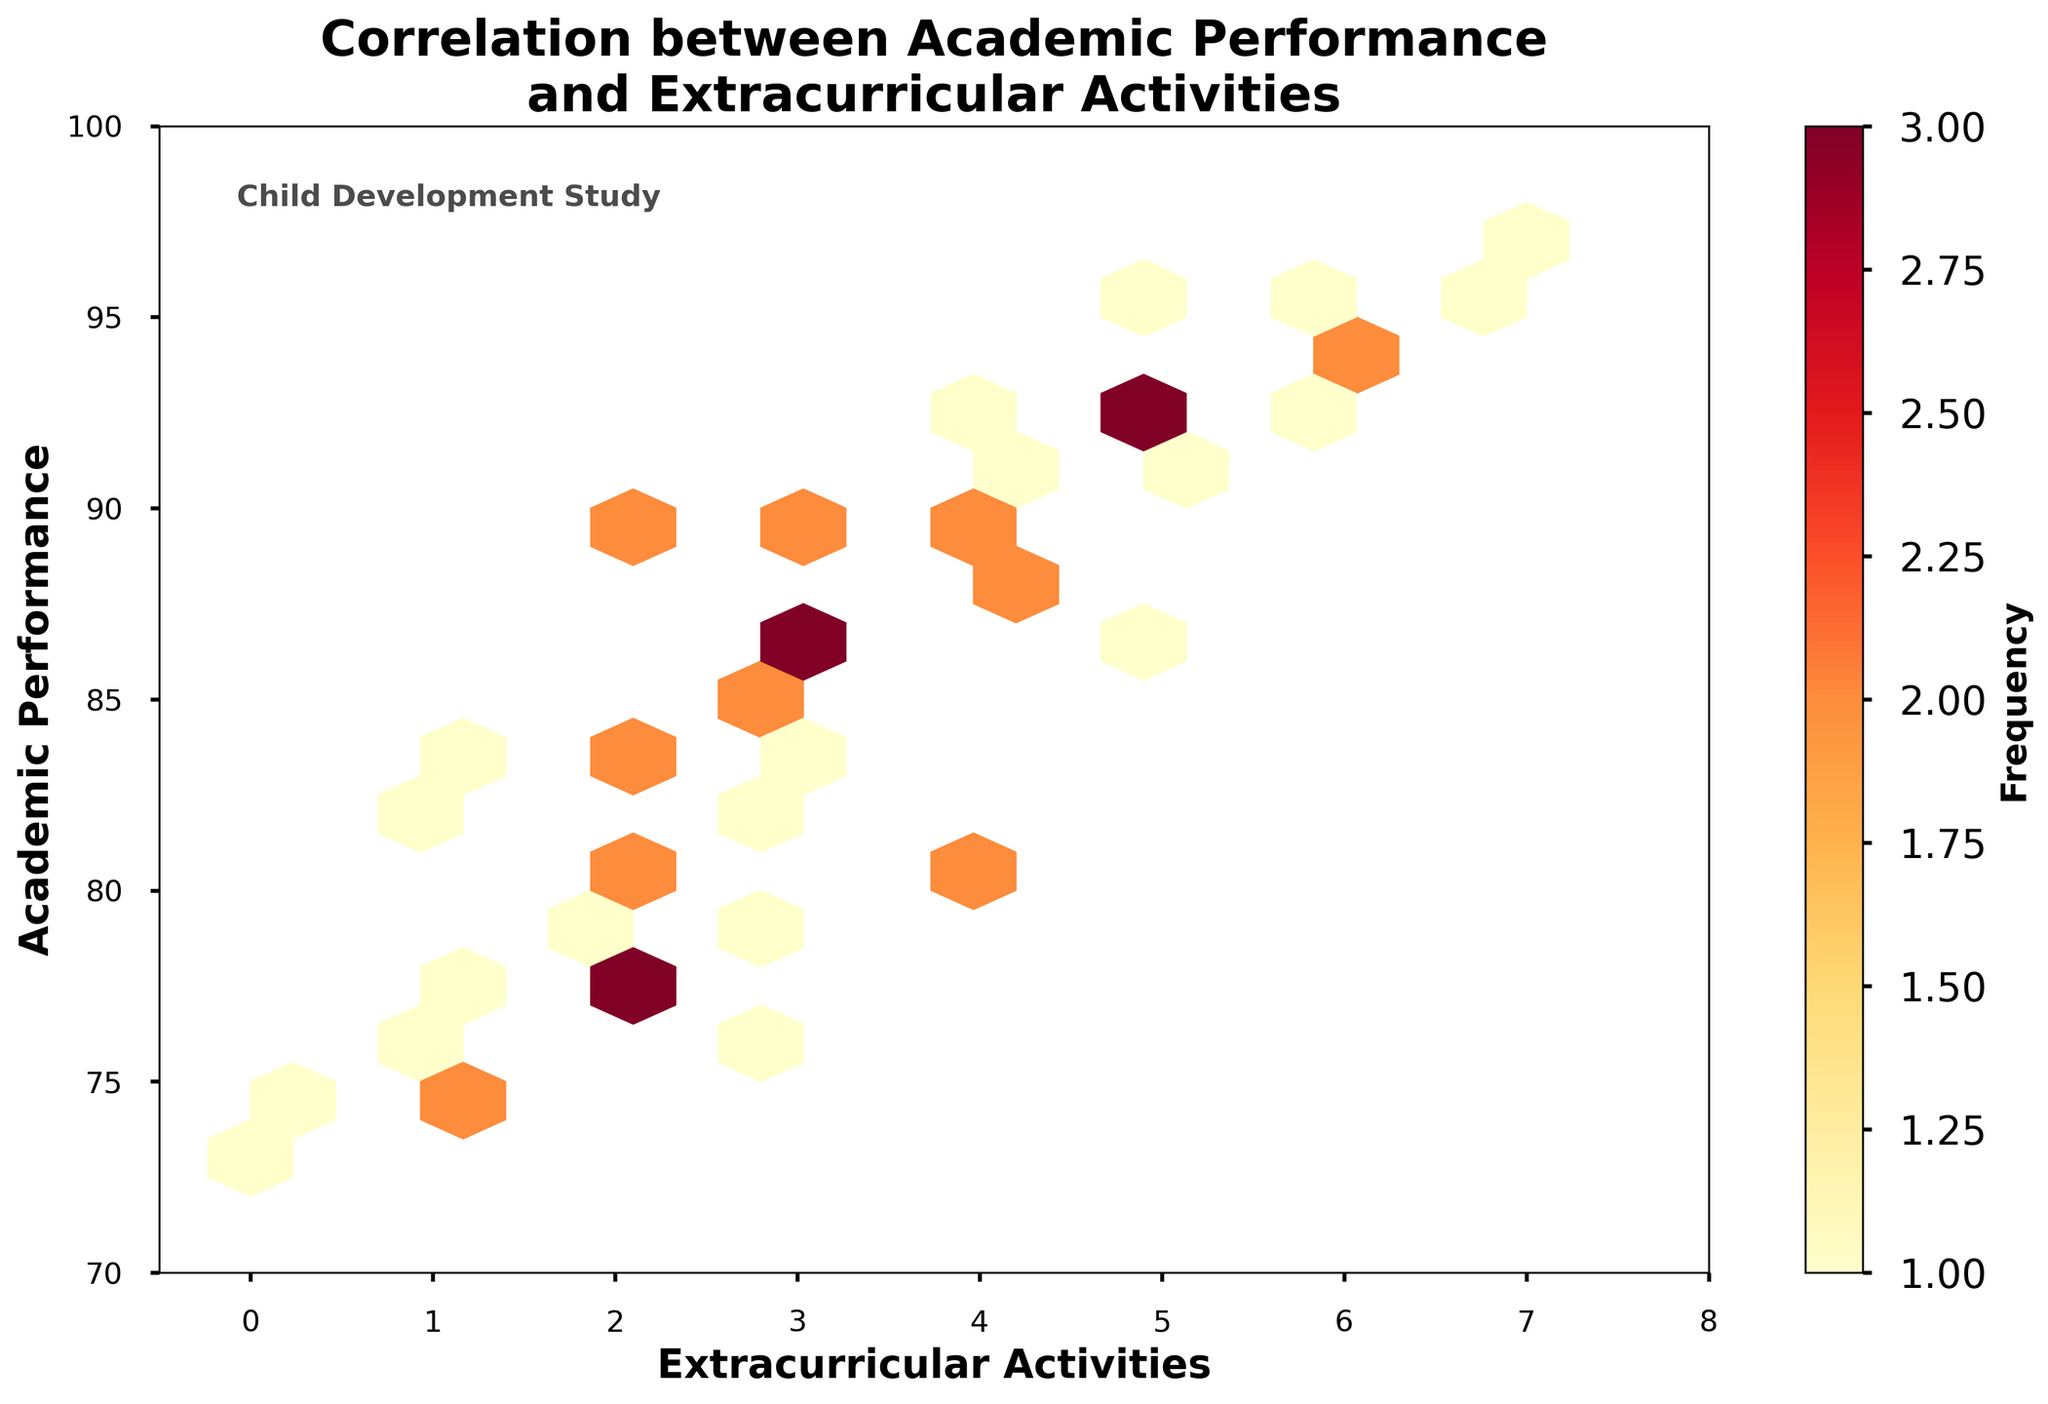How many extracurricular activities are measured on the x-axis? The x-axis represents the number of extracurricular activities, and it ranges from -0.5 to 8, indicating the measurements for 0 to 8 activities.
Answer: 8 What title appears on the plot? The title is located at the top of the plot and reads "Correlation between Academic Performance and Extracurricular Activities."
Answer: Correlation between Academic Performance and Extracurricular Activities What does the color intensity represent in the hexbin plot? The color intensity in the hexbin plot represents the frequency of data points within each hexagonal bin. Darker colors indicate higher frequencies, while lighter colors indicate lower frequencies.
Answer: Frequency What is the range of academic performance scores on the y-axis? The y-axis represents academic performance scores, and it ranges from 70 to 100.
Answer: 70 to 100 What does the color bar to the right side of the plot indicate? The color bar indicates the frequency of data points in each hexagonal bin, with the label clearly stating "Frequency."
Answer: Frequency How many extracurricular activities seem to correlate with the highest academic performance? Observing the densest areas with the darkest hexagons on the plot indicates that students participating in 4 to 6 extracurricular activities correlate with the highest academic performance scores (90-100).
Answer: 4 to 6 Is there a visible correlation between academic performance and extracurricular activities? By analyzing the density and distribution of the hexagonal bins, there's an observable trend that higher numbers of extracurricular activities generally correlate with higher academic performance scores.
Answer: Yes Does any student with zero extracurricular activities perform above 85 in academic performance? Observing the hexagonal bins clustered around 0 extracurricular activities, it is clear that no students in this category have academic performance scores above 85.
Answer: No Which range of extracurricular activities shows the highest frequency of students? Observing the densest regions in the hexbin plot reveals that the range of 4 to 5 extracurricular activities shows the highest frequency of students, indicated by the darkest hexagons in this range.
Answer: 4 to 5 What is the maximum number of extracurricular activities observed in the dataset? The x-axis extends to 8, indicating that the maximum number of extracurricular activities recorded in the dataset is 8.
Answer: 8 